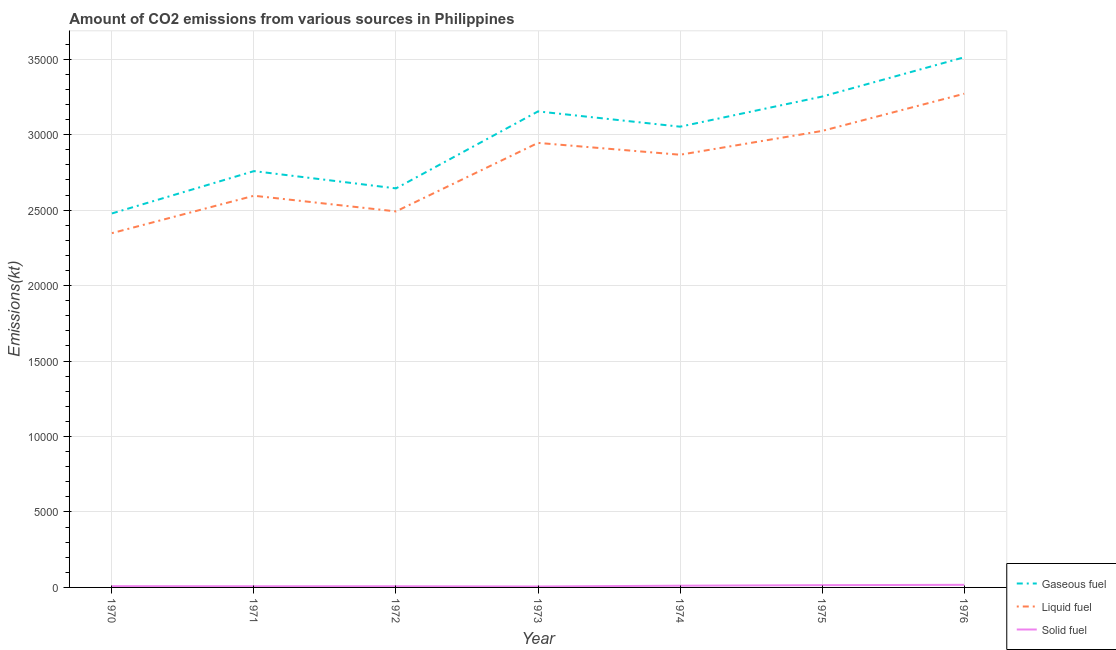How many different coloured lines are there?
Make the answer very short. 3. Does the line corresponding to amount of co2 emissions from gaseous fuel intersect with the line corresponding to amount of co2 emissions from liquid fuel?
Your answer should be very brief. No. What is the amount of co2 emissions from liquid fuel in 1975?
Give a very brief answer. 3.02e+04. Across all years, what is the maximum amount of co2 emissions from gaseous fuel?
Keep it short and to the point. 3.51e+04. Across all years, what is the minimum amount of co2 emissions from solid fuel?
Make the answer very short. 62.34. In which year was the amount of co2 emissions from liquid fuel maximum?
Keep it short and to the point. 1976. What is the total amount of co2 emissions from liquid fuel in the graph?
Provide a short and direct response. 1.95e+05. What is the difference between the amount of co2 emissions from gaseous fuel in 1973 and that in 1974?
Provide a short and direct response. 1012.09. What is the difference between the amount of co2 emissions from gaseous fuel in 1973 and the amount of co2 emissions from liquid fuel in 1976?
Your answer should be very brief. -1169.77. What is the average amount of co2 emissions from gaseous fuel per year?
Your answer should be very brief. 2.98e+04. In the year 1971, what is the difference between the amount of co2 emissions from liquid fuel and amount of co2 emissions from gaseous fuel?
Provide a succinct answer. -1631.81. What is the ratio of the amount of co2 emissions from solid fuel in 1972 to that in 1976?
Offer a terse response. 0.45. What is the difference between the highest and the second highest amount of co2 emissions from gaseous fuel?
Your response must be concise. 2603.57. What is the difference between the highest and the lowest amount of co2 emissions from liquid fuel?
Provide a succinct answer. 9237.17. In how many years, is the amount of co2 emissions from solid fuel greater than the average amount of co2 emissions from solid fuel taken over all years?
Your response must be concise. 3. Is it the case that in every year, the sum of the amount of co2 emissions from gaseous fuel and amount of co2 emissions from liquid fuel is greater than the amount of co2 emissions from solid fuel?
Your answer should be very brief. Yes. What is the difference between two consecutive major ticks on the Y-axis?
Keep it short and to the point. 5000. Are the values on the major ticks of Y-axis written in scientific E-notation?
Your answer should be very brief. No. What is the title of the graph?
Provide a succinct answer. Amount of CO2 emissions from various sources in Philippines. What is the label or title of the Y-axis?
Offer a terse response. Emissions(kt). What is the Emissions(kt) of Gaseous fuel in 1970?
Your answer should be very brief. 2.48e+04. What is the Emissions(kt) in Liquid fuel in 1970?
Give a very brief answer. 2.35e+04. What is the Emissions(kt) in Solid fuel in 1970?
Provide a short and direct response. 84.34. What is the Emissions(kt) of Gaseous fuel in 1971?
Your answer should be compact. 2.76e+04. What is the Emissions(kt) of Liquid fuel in 1971?
Your answer should be compact. 2.60e+04. What is the Emissions(kt) in Solid fuel in 1971?
Your response must be concise. 77.01. What is the Emissions(kt) in Gaseous fuel in 1972?
Make the answer very short. 2.64e+04. What is the Emissions(kt) of Liquid fuel in 1972?
Make the answer very short. 2.49e+04. What is the Emissions(kt) of Solid fuel in 1972?
Ensure brevity in your answer.  77.01. What is the Emissions(kt) in Gaseous fuel in 1973?
Give a very brief answer. 3.15e+04. What is the Emissions(kt) in Liquid fuel in 1973?
Your answer should be very brief. 2.95e+04. What is the Emissions(kt) of Solid fuel in 1973?
Offer a very short reply. 62.34. What is the Emissions(kt) in Gaseous fuel in 1974?
Offer a very short reply. 3.05e+04. What is the Emissions(kt) in Liquid fuel in 1974?
Ensure brevity in your answer.  2.87e+04. What is the Emissions(kt) in Solid fuel in 1974?
Provide a short and direct response. 113.68. What is the Emissions(kt) of Gaseous fuel in 1975?
Your response must be concise. 3.25e+04. What is the Emissions(kt) in Liquid fuel in 1975?
Make the answer very short. 3.02e+04. What is the Emissions(kt) of Solid fuel in 1975?
Provide a short and direct response. 150.35. What is the Emissions(kt) in Gaseous fuel in 1976?
Ensure brevity in your answer.  3.51e+04. What is the Emissions(kt) of Liquid fuel in 1976?
Your answer should be compact. 3.27e+04. What is the Emissions(kt) of Solid fuel in 1976?
Make the answer very short. 172.35. Across all years, what is the maximum Emissions(kt) of Gaseous fuel?
Keep it short and to the point. 3.51e+04. Across all years, what is the maximum Emissions(kt) in Liquid fuel?
Keep it short and to the point. 3.27e+04. Across all years, what is the maximum Emissions(kt) of Solid fuel?
Give a very brief answer. 172.35. Across all years, what is the minimum Emissions(kt) in Gaseous fuel?
Ensure brevity in your answer.  2.48e+04. Across all years, what is the minimum Emissions(kt) in Liquid fuel?
Provide a short and direct response. 2.35e+04. Across all years, what is the minimum Emissions(kt) of Solid fuel?
Offer a very short reply. 62.34. What is the total Emissions(kt) in Gaseous fuel in the graph?
Your answer should be compact. 2.09e+05. What is the total Emissions(kt) of Liquid fuel in the graph?
Give a very brief answer. 1.95e+05. What is the total Emissions(kt) of Solid fuel in the graph?
Your response must be concise. 737.07. What is the difference between the Emissions(kt) of Gaseous fuel in 1970 and that in 1971?
Offer a terse response. -2805.26. What is the difference between the Emissions(kt) of Liquid fuel in 1970 and that in 1971?
Ensure brevity in your answer.  -2478.89. What is the difference between the Emissions(kt) of Solid fuel in 1970 and that in 1971?
Provide a short and direct response. 7.33. What is the difference between the Emissions(kt) in Gaseous fuel in 1970 and that in 1972?
Ensure brevity in your answer.  -1661.15. What is the difference between the Emissions(kt) of Liquid fuel in 1970 and that in 1972?
Offer a very short reply. -1441.13. What is the difference between the Emissions(kt) of Solid fuel in 1970 and that in 1972?
Your response must be concise. 7.33. What is the difference between the Emissions(kt) in Gaseous fuel in 1970 and that in 1973?
Ensure brevity in your answer.  -6761.95. What is the difference between the Emissions(kt) of Liquid fuel in 1970 and that in 1973?
Your response must be concise. -5980.88. What is the difference between the Emissions(kt) in Solid fuel in 1970 and that in 1973?
Offer a terse response. 22. What is the difference between the Emissions(kt) in Gaseous fuel in 1970 and that in 1974?
Offer a terse response. -5749.86. What is the difference between the Emissions(kt) of Liquid fuel in 1970 and that in 1974?
Your response must be concise. -5196.14. What is the difference between the Emissions(kt) in Solid fuel in 1970 and that in 1974?
Your response must be concise. -29.34. What is the difference between the Emissions(kt) in Gaseous fuel in 1970 and that in 1975?
Offer a very short reply. -7744.7. What is the difference between the Emissions(kt) in Liquid fuel in 1970 and that in 1975?
Offer a very short reply. -6772.95. What is the difference between the Emissions(kt) in Solid fuel in 1970 and that in 1975?
Make the answer very short. -66.01. What is the difference between the Emissions(kt) in Gaseous fuel in 1970 and that in 1976?
Your response must be concise. -1.03e+04. What is the difference between the Emissions(kt) of Liquid fuel in 1970 and that in 1976?
Make the answer very short. -9237.17. What is the difference between the Emissions(kt) in Solid fuel in 1970 and that in 1976?
Offer a terse response. -88.01. What is the difference between the Emissions(kt) of Gaseous fuel in 1971 and that in 1972?
Offer a very short reply. 1144.1. What is the difference between the Emissions(kt) in Liquid fuel in 1971 and that in 1972?
Your answer should be very brief. 1037.76. What is the difference between the Emissions(kt) of Solid fuel in 1971 and that in 1972?
Give a very brief answer. 0. What is the difference between the Emissions(kt) of Gaseous fuel in 1971 and that in 1973?
Provide a succinct answer. -3956.69. What is the difference between the Emissions(kt) of Liquid fuel in 1971 and that in 1973?
Give a very brief answer. -3501.99. What is the difference between the Emissions(kt) in Solid fuel in 1971 and that in 1973?
Ensure brevity in your answer.  14.67. What is the difference between the Emissions(kt) in Gaseous fuel in 1971 and that in 1974?
Give a very brief answer. -2944.6. What is the difference between the Emissions(kt) of Liquid fuel in 1971 and that in 1974?
Provide a succinct answer. -2717.25. What is the difference between the Emissions(kt) of Solid fuel in 1971 and that in 1974?
Offer a terse response. -36.67. What is the difference between the Emissions(kt) in Gaseous fuel in 1971 and that in 1975?
Keep it short and to the point. -4939.45. What is the difference between the Emissions(kt) of Liquid fuel in 1971 and that in 1975?
Give a very brief answer. -4294.06. What is the difference between the Emissions(kt) in Solid fuel in 1971 and that in 1975?
Keep it short and to the point. -73.34. What is the difference between the Emissions(kt) of Gaseous fuel in 1971 and that in 1976?
Keep it short and to the point. -7543.02. What is the difference between the Emissions(kt) in Liquid fuel in 1971 and that in 1976?
Your answer should be very brief. -6758.28. What is the difference between the Emissions(kt) in Solid fuel in 1971 and that in 1976?
Offer a very short reply. -95.34. What is the difference between the Emissions(kt) in Gaseous fuel in 1972 and that in 1973?
Give a very brief answer. -5100.8. What is the difference between the Emissions(kt) in Liquid fuel in 1972 and that in 1973?
Your answer should be compact. -4539.75. What is the difference between the Emissions(kt) in Solid fuel in 1972 and that in 1973?
Provide a short and direct response. 14.67. What is the difference between the Emissions(kt) in Gaseous fuel in 1972 and that in 1974?
Your answer should be very brief. -4088.7. What is the difference between the Emissions(kt) in Liquid fuel in 1972 and that in 1974?
Make the answer very short. -3755.01. What is the difference between the Emissions(kt) of Solid fuel in 1972 and that in 1974?
Your response must be concise. -36.67. What is the difference between the Emissions(kt) in Gaseous fuel in 1972 and that in 1975?
Keep it short and to the point. -6083.55. What is the difference between the Emissions(kt) of Liquid fuel in 1972 and that in 1975?
Ensure brevity in your answer.  -5331.82. What is the difference between the Emissions(kt) of Solid fuel in 1972 and that in 1975?
Your answer should be very brief. -73.34. What is the difference between the Emissions(kt) of Gaseous fuel in 1972 and that in 1976?
Offer a terse response. -8687.12. What is the difference between the Emissions(kt) in Liquid fuel in 1972 and that in 1976?
Provide a succinct answer. -7796.04. What is the difference between the Emissions(kt) in Solid fuel in 1972 and that in 1976?
Make the answer very short. -95.34. What is the difference between the Emissions(kt) of Gaseous fuel in 1973 and that in 1974?
Provide a short and direct response. 1012.09. What is the difference between the Emissions(kt) in Liquid fuel in 1973 and that in 1974?
Offer a terse response. 784.74. What is the difference between the Emissions(kt) of Solid fuel in 1973 and that in 1974?
Ensure brevity in your answer.  -51.34. What is the difference between the Emissions(kt) of Gaseous fuel in 1973 and that in 1975?
Offer a terse response. -982.76. What is the difference between the Emissions(kt) of Liquid fuel in 1973 and that in 1975?
Your response must be concise. -792.07. What is the difference between the Emissions(kt) of Solid fuel in 1973 and that in 1975?
Ensure brevity in your answer.  -88.01. What is the difference between the Emissions(kt) of Gaseous fuel in 1973 and that in 1976?
Make the answer very short. -3586.33. What is the difference between the Emissions(kt) of Liquid fuel in 1973 and that in 1976?
Provide a succinct answer. -3256.3. What is the difference between the Emissions(kt) of Solid fuel in 1973 and that in 1976?
Your answer should be compact. -110.01. What is the difference between the Emissions(kt) of Gaseous fuel in 1974 and that in 1975?
Make the answer very short. -1994.85. What is the difference between the Emissions(kt) in Liquid fuel in 1974 and that in 1975?
Give a very brief answer. -1576.81. What is the difference between the Emissions(kt) in Solid fuel in 1974 and that in 1975?
Give a very brief answer. -36.67. What is the difference between the Emissions(kt) in Gaseous fuel in 1974 and that in 1976?
Your response must be concise. -4598.42. What is the difference between the Emissions(kt) of Liquid fuel in 1974 and that in 1976?
Provide a succinct answer. -4041.03. What is the difference between the Emissions(kt) in Solid fuel in 1974 and that in 1976?
Provide a short and direct response. -58.67. What is the difference between the Emissions(kt) in Gaseous fuel in 1975 and that in 1976?
Make the answer very short. -2603.57. What is the difference between the Emissions(kt) in Liquid fuel in 1975 and that in 1976?
Offer a terse response. -2464.22. What is the difference between the Emissions(kt) in Solid fuel in 1975 and that in 1976?
Ensure brevity in your answer.  -22. What is the difference between the Emissions(kt) of Gaseous fuel in 1970 and the Emissions(kt) of Liquid fuel in 1971?
Ensure brevity in your answer.  -1173.44. What is the difference between the Emissions(kt) in Gaseous fuel in 1970 and the Emissions(kt) in Solid fuel in 1971?
Make the answer very short. 2.47e+04. What is the difference between the Emissions(kt) in Liquid fuel in 1970 and the Emissions(kt) in Solid fuel in 1971?
Your answer should be very brief. 2.34e+04. What is the difference between the Emissions(kt) of Gaseous fuel in 1970 and the Emissions(kt) of Liquid fuel in 1972?
Give a very brief answer. -135.68. What is the difference between the Emissions(kt) of Gaseous fuel in 1970 and the Emissions(kt) of Solid fuel in 1972?
Provide a succinct answer. 2.47e+04. What is the difference between the Emissions(kt) in Liquid fuel in 1970 and the Emissions(kt) in Solid fuel in 1972?
Make the answer very short. 2.34e+04. What is the difference between the Emissions(kt) in Gaseous fuel in 1970 and the Emissions(kt) in Liquid fuel in 1973?
Ensure brevity in your answer.  -4675.43. What is the difference between the Emissions(kt) in Gaseous fuel in 1970 and the Emissions(kt) in Solid fuel in 1973?
Offer a terse response. 2.47e+04. What is the difference between the Emissions(kt) in Liquid fuel in 1970 and the Emissions(kt) in Solid fuel in 1973?
Keep it short and to the point. 2.34e+04. What is the difference between the Emissions(kt) of Gaseous fuel in 1970 and the Emissions(kt) of Liquid fuel in 1974?
Offer a very short reply. -3890.69. What is the difference between the Emissions(kt) of Gaseous fuel in 1970 and the Emissions(kt) of Solid fuel in 1974?
Offer a terse response. 2.47e+04. What is the difference between the Emissions(kt) of Liquid fuel in 1970 and the Emissions(kt) of Solid fuel in 1974?
Your answer should be compact. 2.34e+04. What is the difference between the Emissions(kt) of Gaseous fuel in 1970 and the Emissions(kt) of Liquid fuel in 1975?
Offer a very short reply. -5467.5. What is the difference between the Emissions(kt) in Gaseous fuel in 1970 and the Emissions(kt) in Solid fuel in 1975?
Offer a very short reply. 2.46e+04. What is the difference between the Emissions(kt) in Liquid fuel in 1970 and the Emissions(kt) in Solid fuel in 1975?
Give a very brief answer. 2.33e+04. What is the difference between the Emissions(kt) in Gaseous fuel in 1970 and the Emissions(kt) in Liquid fuel in 1976?
Ensure brevity in your answer.  -7931.72. What is the difference between the Emissions(kt) of Gaseous fuel in 1970 and the Emissions(kt) of Solid fuel in 1976?
Ensure brevity in your answer.  2.46e+04. What is the difference between the Emissions(kt) of Liquid fuel in 1970 and the Emissions(kt) of Solid fuel in 1976?
Make the answer very short. 2.33e+04. What is the difference between the Emissions(kt) of Gaseous fuel in 1971 and the Emissions(kt) of Liquid fuel in 1972?
Your answer should be compact. 2669.58. What is the difference between the Emissions(kt) in Gaseous fuel in 1971 and the Emissions(kt) in Solid fuel in 1972?
Ensure brevity in your answer.  2.75e+04. What is the difference between the Emissions(kt) of Liquid fuel in 1971 and the Emissions(kt) of Solid fuel in 1972?
Give a very brief answer. 2.59e+04. What is the difference between the Emissions(kt) of Gaseous fuel in 1971 and the Emissions(kt) of Liquid fuel in 1973?
Keep it short and to the point. -1870.17. What is the difference between the Emissions(kt) in Gaseous fuel in 1971 and the Emissions(kt) in Solid fuel in 1973?
Your response must be concise. 2.75e+04. What is the difference between the Emissions(kt) in Liquid fuel in 1971 and the Emissions(kt) in Solid fuel in 1973?
Provide a short and direct response. 2.59e+04. What is the difference between the Emissions(kt) of Gaseous fuel in 1971 and the Emissions(kt) of Liquid fuel in 1974?
Keep it short and to the point. -1085.43. What is the difference between the Emissions(kt) of Gaseous fuel in 1971 and the Emissions(kt) of Solid fuel in 1974?
Offer a terse response. 2.75e+04. What is the difference between the Emissions(kt) in Liquid fuel in 1971 and the Emissions(kt) in Solid fuel in 1974?
Ensure brevity in your answer.  2.58e+04. What is the difference between the Emissions(kt) in Gaseous fuel in 1971 and the Emissions(kt) in Liquid fuel in 1975?
Make the answer very short. -2662.24. What is the difference between the Emissions(kt) in Gaseous fuel in 1971 and the Emissions(kt) in Solid fuel in 1975?
Provide a short and direct response. 2.74e+04. What is the difference between the Emissions(kt) of Liquid fuel in 1971 and the Emissions(kt) of Solid fuel in 1975?
Ensure brevity in your answer.  2.58e+04. What is the difference between the Emissions(kt) of Gaseous fuel in 1971 and the Emissions(kt) of Liquid fuel in 1976?
Your answer should be very brief. -5126.47. What is the difference between the Emissions(kt) of Gaseous fuel in 1971 and the Emissions(kt) of Solid fuel in 1976?
Offer a terse response. 2.74e+04. What is the difference between the Emissions(kt) in Liquid fuel in 1971 and the Emissions(kt) in Solid fuel in 1976?
Offer a very short reply. 2.58e+04. What is the difference between the Emissions(kt) in Gaseous fuel in 1972 and the Emissions(kt) in Liquid fuel in 1973?
Give a very brief answer. -3014.27. What is the difference between the Emissions(kt) of Gaseous fuel in 1972 and the Emissions(kt) of Solid fuel in 1973?
Your response must be concise. 2.64e+04. What is the difference between the Emissions(kt) in Liquid fuel in 1972 and the Emissions(kt) in Solid fuel in 1973?
Keep it short and to the point. 2.49e+04. What is the difference between the Emissions(kt) of Gaseous fuel in 1972 and the Emissions(kt) of Liquid fuel in 1974?
Make the answer very short. -2229.54. What is the difference between the Emissions(kt) in Gaseous fuel in 1972 and the Emissions(kt) in Solid fuel in 1974?
Give a very brief answer. 2.63e+04. What is the difference between the Emissions(kt) of Liquid fuel in 1972 and the Emissions(kt) of Solid fuel in 1974?
Provide a succinct answer. 2.48e+04. What is the difference between the Emissions(kt) of Gaseous fuel in 1972 and the Emissions(kt) of Liquid fuel in 1975?
Ensure brevity in your answer.  -3806.35. What is the difference between the Emissions(kt) of Gaseous fuel in 1972 and the Emissions(kt) of Solid fuel in 1975?
Give a very brief answer. 2.63e+04. What is the difference between the Emissions(kt) of Liquid fuel in 1972 and the Emissions(kt) of Solid fuel in 1975?
Keep it short and to the point. 2.48e+04. What is the difference between the Emissions(kt) of Gaseous fuel in 1972 and the Emissions(kt) of Liquid fuel in 1976?
Provide a succinct answer. -6270.57. What is the difference between the Emissions(kt) in Gaseous fuel in 1972 and the Emissions(kt) in Solid fuel in 1976?
Keep it short and to the point. 2.63e+04. What is the difference between the Emissions(kt) of Liquid fuel in 1972 and the Emissions(kt) of Solid fuel in 1976?
Your response must be concise. 2.47e+04. What is the difference between the Emissions(kt) of Gaseous fuel in 1973 and the Emissions(kt) of Liquid fuel in 1974?
Give a very brief answer. 2871.26. What is the difference between the Emissions(kt) in Gaseous fuel in 1973 and the Emissions(kt) in Solid fuel in 1974?
Offer a very short reply. 3.14e+04. What is the difference between the Emissions(kt) of Liquid fuel in 1973 and the Emissions(kt) of Solid fuel in 1974?
Provide a succinct answer. 2.93e+04. What is the difference between the Emissions(kt) in Gaseous fuel in 1973 and the Emissions(kt) in Liquid fuel in 1975?
Ensure brevity in your answer.  1294.45. What is the difference between the Emissions(kt) of Gaseous fuel in 1973 and the Emissions(kt) of Solid fuel in 1975?
Give a very brief answer. 3.14e+04. What is the difference between the Emissions(kt) in Liquid fuel in 1973 and the Emissions(kt) in Solid fuel in 1975?
Make the answer very short. 2.93e+04. What is the difference between the Emissions(kt) of Gaseous fuel in 1973 and the Emissions(kt) of Liquid fuel in 1976?
Ensure brevity in your answer.  -1169.77. What is the difference between the Emissions(kt) of Gaseous fuel in 1973 and the Emissions(kt) of Solid fuel in 1976?
Your answer should be compact. 3.14e+04. What is the difference between the Emissions(kt) of Liquid fuel in 1973 and the Emissions(kt) of Solid fuel in 1976?
Offer a terse response. 2.93e+04. What is the difference between the Emissions(kt) in Gaseous fuel in 1974 and the Emissions(kt) in Liquid fuel in 1975?
Your response must be concise. 282.36. What is the difference between the Emissions(kt) of Gaseous fuel in 1974 and the Emissions(kt) of Solid fuel in 1975?
Your answer should be compact. 3.04e+04. What is the difference between the Emissions(kt) of Liquid fuel in 1974 and the Emissions(kt) of Solid fuel in 1975?
Offer a very short reply. 2.85e+04. What is the difference between the Emissions(kt) of Gaseous fuel in 1974 and the Emissions(kt) of Liquid fuel in 1976?
Ensure brevity in your answer.  -2181.86. What is the difference between the Emissions(kt) of Gaseous fuel in 1974 and the Emissions(kt) of Solid fuel in 1976?
Provide a succinct answer. 3.04e+04. What is the difference between the Emissions(kt) of Liquid fuel in 1974 and the Emissions(kt) of Solid fuel in 1976?
Keep it short and to the point. 2.85e+04. What is the difference between the Emissions(kt) of Gaseous fuel in 1975 and the Emissions(kt) of Liquid fuel in 1976?
Keep it short and to the point. -187.02. What is the difference between the Emissions(kt) in Gaseous fuel in 1975 and the Emissions(kt) in Solid fuel in 1976?
Your answer should be very brief. 3.24e+04. What is the difference between the Emissions(kt) in Liquid fuel in 1975 and the Emissions(kt) in Solid fuel in 1976?
Make the answer very short. 3.01e+04. What is the average Emissions(kt) of Gaseous fuel per year?
Your response must be concise. 2.98e+04. What is the average Emissions(kt) of Liquid fuel per year?
Keep it short and to the point. 2.79e+04. What is the average Emissions(kt) of Solid fuel per year?
Your response must be concise. 105.3. In the year 1970, what is the difference between the Emissions(kt) of Gaseous fuel and Emissions(kt) of Liquid fuel?
Your answer should be very brief. 1305.45. In the year 1970, what is the difference between the Emissions(kt) of Gaseous fuel and Emissions(kt) of Solid fuel?
Your response must be concise. 2.47e+04. In the year 1970, what is the difference between the Emissions(kt) of Liquid fuel and Emissions(kt) of Solid fuel?
Provide a short and direct response. 2.34e+04. In the year 1971, what is the difference between the Emissions(kt) of Gaseous fuel and Emissions(kt) of Liquid fuel?
Your answer should be very brief. 1631.82. In the year 1971, what is the difference between the Emissions(kt) in Gaseous fuel and Emissions(kt) in Solid fuel?
Your response must be concise. 2.75e+04. In the year 1971, what is the difference between the Emissions(kt) of Liquid fuel and Emissions(kt) of Solid fuel?
Ensure brevity in your answer.  2.59e+04. In the year 1972, what is the difference between the Emissions(kt) in Gaseous fuel and Emissions(kt) in Liquid fuel?
Your answer should be very brief. 1525.47. In the year 1972, what is the difference between the Emissions(kt) in Gaseous fuel and Emissions(kt) in Solid fuel?
Keep it short and to the point. 2.64e+04. In the year 1972, what is the difference between the Emissions(kt) of Liquid fuel and Emissions(kt) of Solid fuel?
Your response must be concise. 2.48e+04. In the year 1973, what is the difference between the Emissions(kt) of Gaseous fuel and Emissions(kt) of Liquid fuel?
Give a very brief answer. 2086.52. In the year 1973, what is the difference between the Emissions(kt) in Gaseous fuel and Emissions(kt) in Solid fuel?
Make the answer very short. 3.15e+04. In the year 1973, what is the difference between the Emissions(kt) in Liquid fuel and Emissions(kt) in Solid fuel?
Your response must be concise. 2.94e+04. In the year 1974, what is the difference between the Emissions(kt) of Gaseous fuel and Emissions(kt) of Liquid fuel?
Your answer should be compact. 1859.17. In the year 1974, what is the difference between the Emissions(kt) of Gaseous fuel and Emissions(kt) of Solid fuel?
Provide a short and direct response. 3.04e+04. In the year 1974, what is the difference between the Emissions(kt) in Liquid fuel and Emissions(kt) in Solid fuel?
Offer a terse response. 2.86e+04. In the year 1975, what is the difference between the Emissions(kt) in Gaseous fuel and Emissions(kt) in Liquid fuel?
Your answer should be compact. 2277.21. In the year 1975, what is the difference between the Emissions(kt) of Gaseous fuel and Emissions(kt) of Solid fuel?
Your answer should be compact. 3.24e+04. In the year 1975, what is the difference between the Emissions(kt) in Liquid fuel and Emissions(kt) in Solid fuel?
Provide a succinct answer. 3.01e+04. In the year 1976, what is the difference between the Emissions(kt) in Gaseous fuel and Emissions(kt) in Liquid fuel?
Provide a succinct answer. 2416.55. In the year 1976, what is the difference between the Emissions(kt) in Gaseous fuel and Emissions(kt) in Solid fuel?
Your answer should be compact. 3.50e+04. In the year 1976, what is the difference between the Emissions(kt) in Liquid fuel and Emissions(kt) in Solid fuel?
Offer a very short reply. 3.25e+04. What is the ratio of the Emissions(kt) in Gaseous fuel in 1970 to that in 1971?
Provide a succinct answer. 0.9. What is the ratio of the Emissions(kt) in Liquid fuel in 1970 to that in 1971?
Provide a short and direct response. 0.9. What is the ratio of the Emissions(kt) of Solid fuel in 1970 to that in 1971?
Your response must be concise. 1.1. What is the ratio of the Emissions(kt) in Gaseous fuel in 1970 to that in 1972?
Offer a terse response. 0.94. What is the ratio of the Emissions(kt) in Liquid fuel in 1970 to that in 1972?
Your response must be concise. 0.94. What is the ratio of the Emissions(kt) of Solid fuel in 1970 to that in 1972?
Offer a terse response. 1.1. What is the ratio of the Emissions(kt) in Gaseous fuel in 1970 to that in 1973?
Your answer should be very brief. 0.79. What is the ratio of the Emissions(kt) of Liquid fuel in 1970 to that in 1973?
Provide a succinct answer. 0.8. What is the ratio of the Emissions(kt) of Solid fuel in 1970 to that in 1973?
Your answer should be compact. 1.35. What is the ratio of the Emissions(kt) in Gaseous fuel in 1970 to that in 1974?
Provide a short and direct response. 0.81. What is the ratio of the Emissions(kt) in Liquid fuel in 1970 to that in 1974?
Give a very brief answer. 0.82. What is the ratio of the Emissions(kt) in Solid fuel in 1970 to that in 1974?
Your response must be concise. 0.74. What is the ratio of the Emissions(kt) in Gaseous fuel in 1970 to that in 1975?
Offer a terse response. 0.76. What is the ratio of the Emissions(kt) in Liquid fuel in 1970 to that in 1975?
Make the answer very short. 0.78. What is the ratio of the Emissions(kt) of Solid fuel in 1970 to that in 1975?
Provide a succinct answer. 0.56. What is the ratio of the Emissions(kt) in Gaseous fuel in 1970 to that in 1976?
Provide a short and direct response. 0.71. What is the ratio of the Emissions(kt) in Liquid fuel in 1970 to that in 1976?
Keep it short and to the point. 0.72. What is the ratio of the Emissions(kt) of Solid fuel in 1970 to that in 1976?
Keep it short and to the point. 0.49. What is the ratio of the Emissions(kt) of Gaseous fuel in 1971 to that in 1972?
Make the answer very short. 1.04. What is the ratio of the Emissions(kt) in Liquid fuel in 1971 to that in 1972?
Your response must be concise. 1.04. What is the ratio of the Emissions(kt) of Solid fuel in 1971 to that in 1972?
Ensure brevity in your answer.  1. What is the ratio of the Emissions(kt) in Gaseous fuel in 1971 to that in 1973?
Your response must be concise. 0.87. What is the ratio of the Emissions(kt) of Liquid fuel in 1971 to that in 1973?
Provide a succinct answer. 0.88. What is the ratio of the Emissions(kt) in Solid fuel in 1971 to that in 1973?
Offer a terse response. 1.24. What is the ratio of the Emissions(kt) in Gaseous fuel in 1971 to that in 1974?
Give a very brief answer. 0.9. What is the ratio of the Emissions(kt) of Liquid fuel in 1971 to that in 1974?
Your response must be concise. 0.91. What is the ratio of the Emissions(kt) in Solid fuel in 1971 to that in 1974?
Your response must be concise. 0.68. What is the ratio of the Emissions(kt) of Gaseous fuel in 1971 to that in 1975?
Offer a terse response. 0.85. What is the ratio of the Emissions(kt) in Liquid fuel in 1971 to that in 1975?
Give a very brief answer. 0.86. What is the ratio of the Emissions(kt) of Solid fuel in 1971 to that in 1975?
Provide a short and direct response. 0.51. What is the ratio of the Emissions(kt) of Gaseous fuel in 1971 to that in 1976?
Ensure brevity in your answer.  0.79. What is the ratio of the Emissions(kt) in Liquid fuel in 1971 to that in 1976?
Give a very brief answer. 0.79. What is the ratio of the Emissions(kt) of Solid fuel in 1971 to that in 1976?
Offer a very short reply. 0.45. What is the ratio of the Emissions(kt) in Gaseous fuel in 1972 to that in 1973?
Ensure brevity in your answer.  0.84. What is the ratio of the Emissions(kt) of Liquid fuel in 1972 to that in 1973?
Provide a succinct answer. 0.85. What is the ratio of the Emissions(kt) of Solid fuel in 1972 to that in 1973?
Offer a terse response. 1.24. What is the ratio of the Emissions(kt) of Gaseous fuel in 1972 to that in 1974?
Your response must be concise. 0.87. What is the ratio of the Emissions(kt) of Liquid fuel in 1972 to that in 1974?
Ensure brevity in your answer.  0.87. What is the ratio of the Emissions(kt) in Solid fuel in 1972 to that in 1974?
Your answer should be very brief. 0.68. What is the ratio of the Emissions(kt) in Gaseous fuel in 1972 to that in 1975?
Offer a terse response. 0.81. What is the ratio of the Emissions(kt) of Liquid fuel in 1972 to that in 1975?
Your answer should be very brief. 0.82. What is the ratio of the Emissions(kt) in Solid fuel in 1972 to that in 1975?
Offer a very short reply. 0.51. What is the ratio of the Emissions(kt) in Gaseous fuel in 1972 to that in 1976?
Your answer should be very brief. 0.75. What is the ratio of the Emissions(kt) in Liquid fuel in 1972 to that in 1976?
Offer a terse response. 0.76. What is the ratio of the Emissions(kt) of Solid fuel in 1972 to that in 1976?
Your answer should be very brief. 0.45. What is the ratio of the Emissions(kt) of Gaseous fuel in 1973 to that in 1974?
Provide a short and direct response. 1.03. What is the ratio of the Emissions(kt) of Liquid fuel in 1973 to that in 1974?
Provide a succinct answer. 1.03. What is the ratio of the Emissions(kt) of Solid fuel in 1973 to that in 1974?
Make the answer very short. 0.55. What is the ratio of the Emissions(kt) in Gaseous fuel in 1973 to that in 1975?
Offer a very short reply. 0.97. What is the ratio of the Emissions(kt) of Liquid fuel in 1973 to that in 1975?
Give a very brief answer. 0.97. What is the ratio of the Emissions(kt) of Solid fuel in 1973 to that in 1975?
Ensure brevity in your answer.  0.41. What is the ratio of the Emissions(kt) in Gaseous fuel in 1973 to that in 1976?
Ensure brevity in your answer.  0.9. What is the ratio of the Emissions(kt) of Liquid fuel in 1973 to that in 1976?
Provide a short and direct response. 0.9. What is the ratio of the Emissions(kt) in Solid fuel in 1973 to that in 1976?
Offer a terse response. 0.36. What is the ratio of the Emissions(kt) in Gaseous fuel in 1974 to that in 1975?
Give a very brief answer. 0.94. What is the ratio of the Emissions(kt) of Liquid fuel in 1974 to that in 1975?
Offer a very short reply. 0.95. What is the ratio of the Emissions(kt) of Solid fuel in 1974 to that in 1975?
Provide a succinct answer. 0.76. What is the ratio of the Emissions(kt) of Gaseous fuel in 1974 to that in 1976?
Offer a terse response. 0.87. What is the ratio of the Emissions(kt) in Liquid fuel in 1974 to that in 1976?
Offer a very short reply. 0.88. What is the ratio of the Emissions(kt) in Solid fuel in 1974 to that in 1976?
Make the answer very short. 0.66. What is the ratio of the Emissions(kt) in Gaseous fuel in 1975 to that in 1976?
Offer a terse response. 0.93. What is the ratio of the Emissions(kt) in Liquid fuel in 1975 to that in 1976?
Make the answer very short. 0.92. What is the ratio of the Emissions(kt) in Solid fuel in 1975 to that in 1976?
Keep it short and to the point. 0.87. What is the difference between the highest and the second highest Emissions(kt) in Gaseous fuel?
Keep it short and to the point. 2603.57. What is the difference between the highest and the second highest Emissions(kt) of Liquid fuel?
Your response must be concise. 2464.22. What is the difference between the highest and the second highest Emissions(kt) of Solid fuel?
Your answer should be very brief. 22. What is the difference between the highest and the lowest Emissions(kt) of Gaseous fuel?
Provide a succinct answer. 1.03e+04. What is the difference between the highest and the lowest Emissions(kt) in Liquid fuel?
Give a very brief answer. 9237.17. What is the difference between the highest and the lowest Emissions(kt) in Solid fuel?
Offer a very short reply. 110.01. 